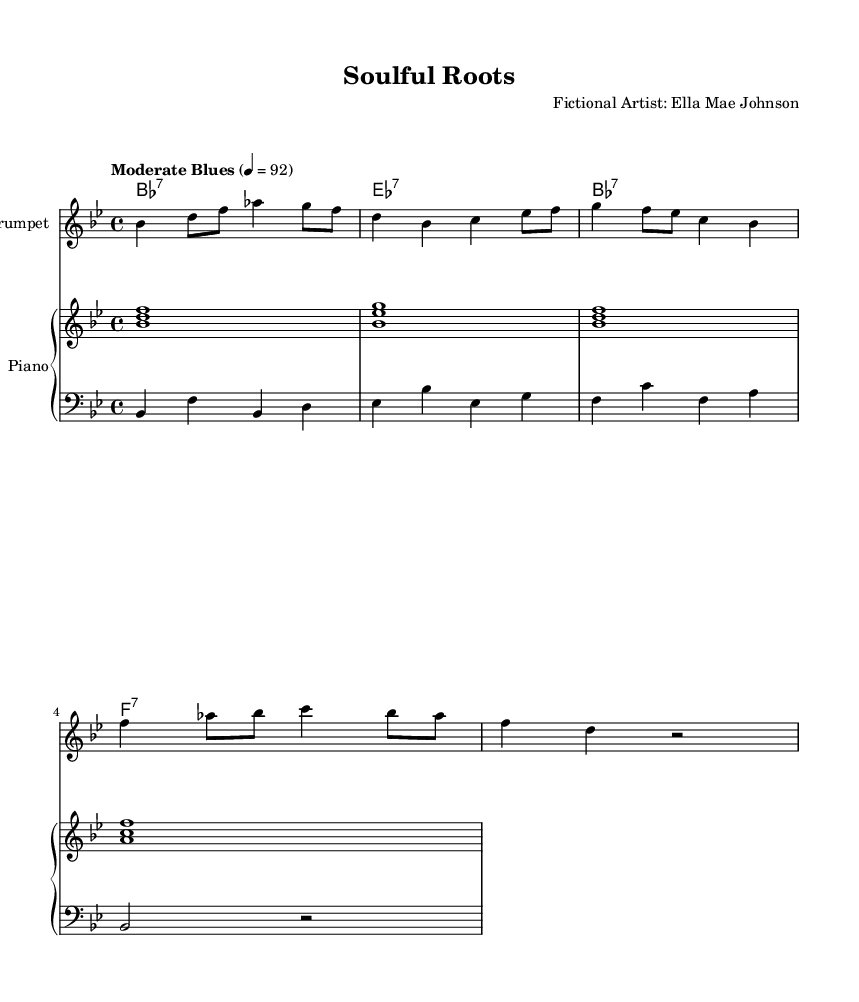What is the key signature of this music? The key signature is indicated by the flat symbol on the second line from the top of the staff, which corresponds to B flat major as it includes B flat and E flat.
Answer: B flat major What is the time signature of this music? The time signature appears at the beginning of the staff and is represented by the numbers 4 and 4, indicating that there are four beats in each measure and the quarter note gets one beat.
Answer: 4/4 What is the tempo marking of the piece? The tempo marking is written at the beginning and indicates the speed of the music. Here, it reads "Moderate Blues" with a metronome marking of 92 beats per minute.
Answer: Moderate Blues Which instrument is featured as the soloist in this piece? The title on the score indicates that the music is arranged for a trumpet part, meaning the trumpet is the featured instrument.
Answer: Trumpet How many measures are there in the trumpet part? By counting the groupings of notes divided by vertical lines on the staff, we find that there are four measures in the trumpet part.
Answer: Four What type of chords are indicated in the chord names? The chord symbols above the staff indicate seventh chords (e.g., B flat seventh, E flat seventh), which are characteristic of blues music.
Answer: Seventh chords Which chords appear in the progression for the piano? The chord names overhead show the sequence of B flat, E flat, B flat, and F, corresponding to the harmonic foundation laid for blues.
Answer: B flat, E flat, F 